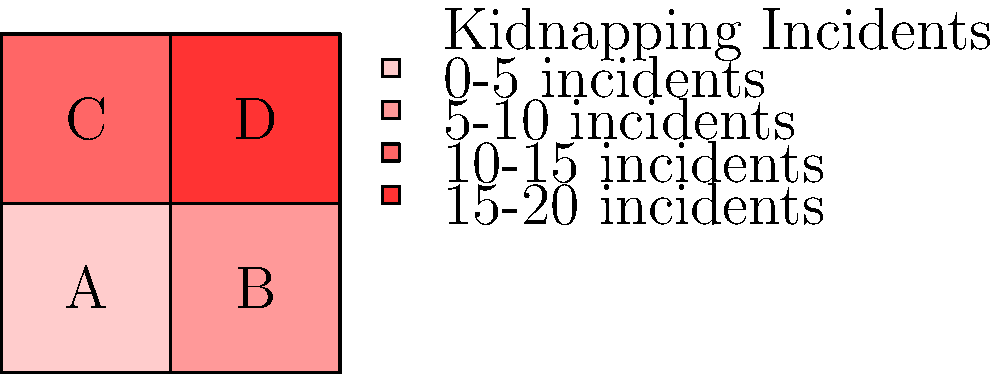Based on the color-coded map of kidnapping incidents in a city divided into four districts (A, B, C, and D), which district should be prioritized for increased security measures and surveillance to prevent future kidnappings? To determine which district should be prioritized for increased security measures, we need to analyze the color-coding of each district:

1. Examine the legend:
   - Lighter shades indicate fewer incidents
   - Darker shades indicate more incidents
   - The scale ranges from 0-5 incidents (lightest) to 15-20 incidents (darkest)

2. Analyze each district:
   - District A (bottom-left): Lightest shade, indicating 0-5 incidents
   - District B (bottom-right): Second lightest shade, indicating 5-10 incidents
   - District C (top-left): Second darkest shade, indicating 10-15 incidents
   - District D (top-right): Darkest shade, indicating 15-20 incidents

3. Compare the districts:
   - District D has the highest number of incidents (15-20)
   - District C has the second-highest number of incidents (10-15)
   - Districts A and B have fewer incidents

4. Conclusion:
   District D should be prioritized for increased security measures and surveillance due to having the highest number of kidnapping incidents.
Answer: District D 